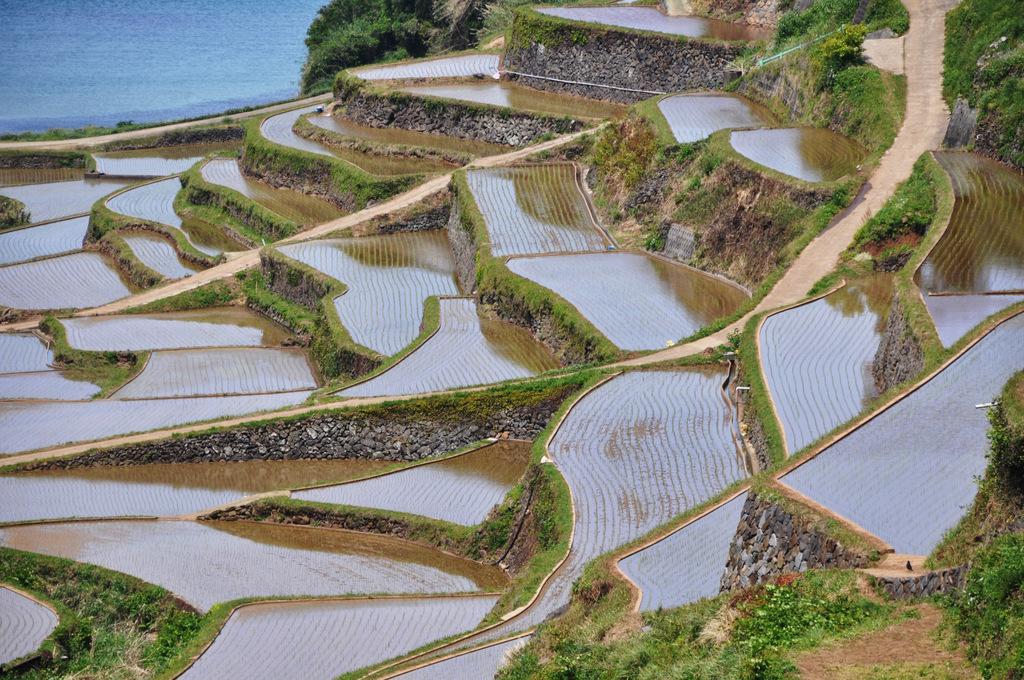Please provide a concise description of this image. This image is clicked near the ocean. There are fields and road in between the fields. It looks a agricultural lands. At the bottom, there is green grass. And there is water in the fields. To the top, there are trees. 